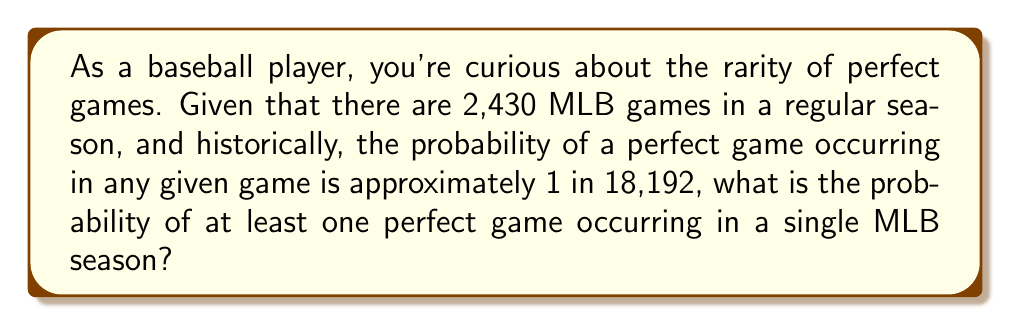Give your solution to this math problem. Let's approach this step-by-step:

1) First, let's calculate the probability of a perfect game not occurring in a single game:
   $P(\text{no perfect game}) = 1 - \frac{1}{18,192} = \frac{18,191}{18,192}$

2) Now, for a perfect game to not occur in an entire season, it must not occur in any of the 2,430 games. We can calculate this probability using the multiplication rule:
   $P(\text{no perfect game in season}) = (\frac{18,191}{18,192})^{2,430}$

3) Therefore, the probability of at least one perfect game in a season is the complement of this probability:
   $P(\text{at least one perfect game}) = 1 - (\frac{18,191}{18,192})^{2,430}$

4) Let's calculate this:
   $1 - (\frac{18,191}{18,192})^{2,430} \approx 1 - 0.8749 = 0.1251$

5) Converting to a percentage:
   $0.1251 \times 100\% \approx 12.51\%$

Thus, there's approximately a 12.51% chance of at least one perfect game occurring in a single MLB season.
Answer: $12.51\%$ 